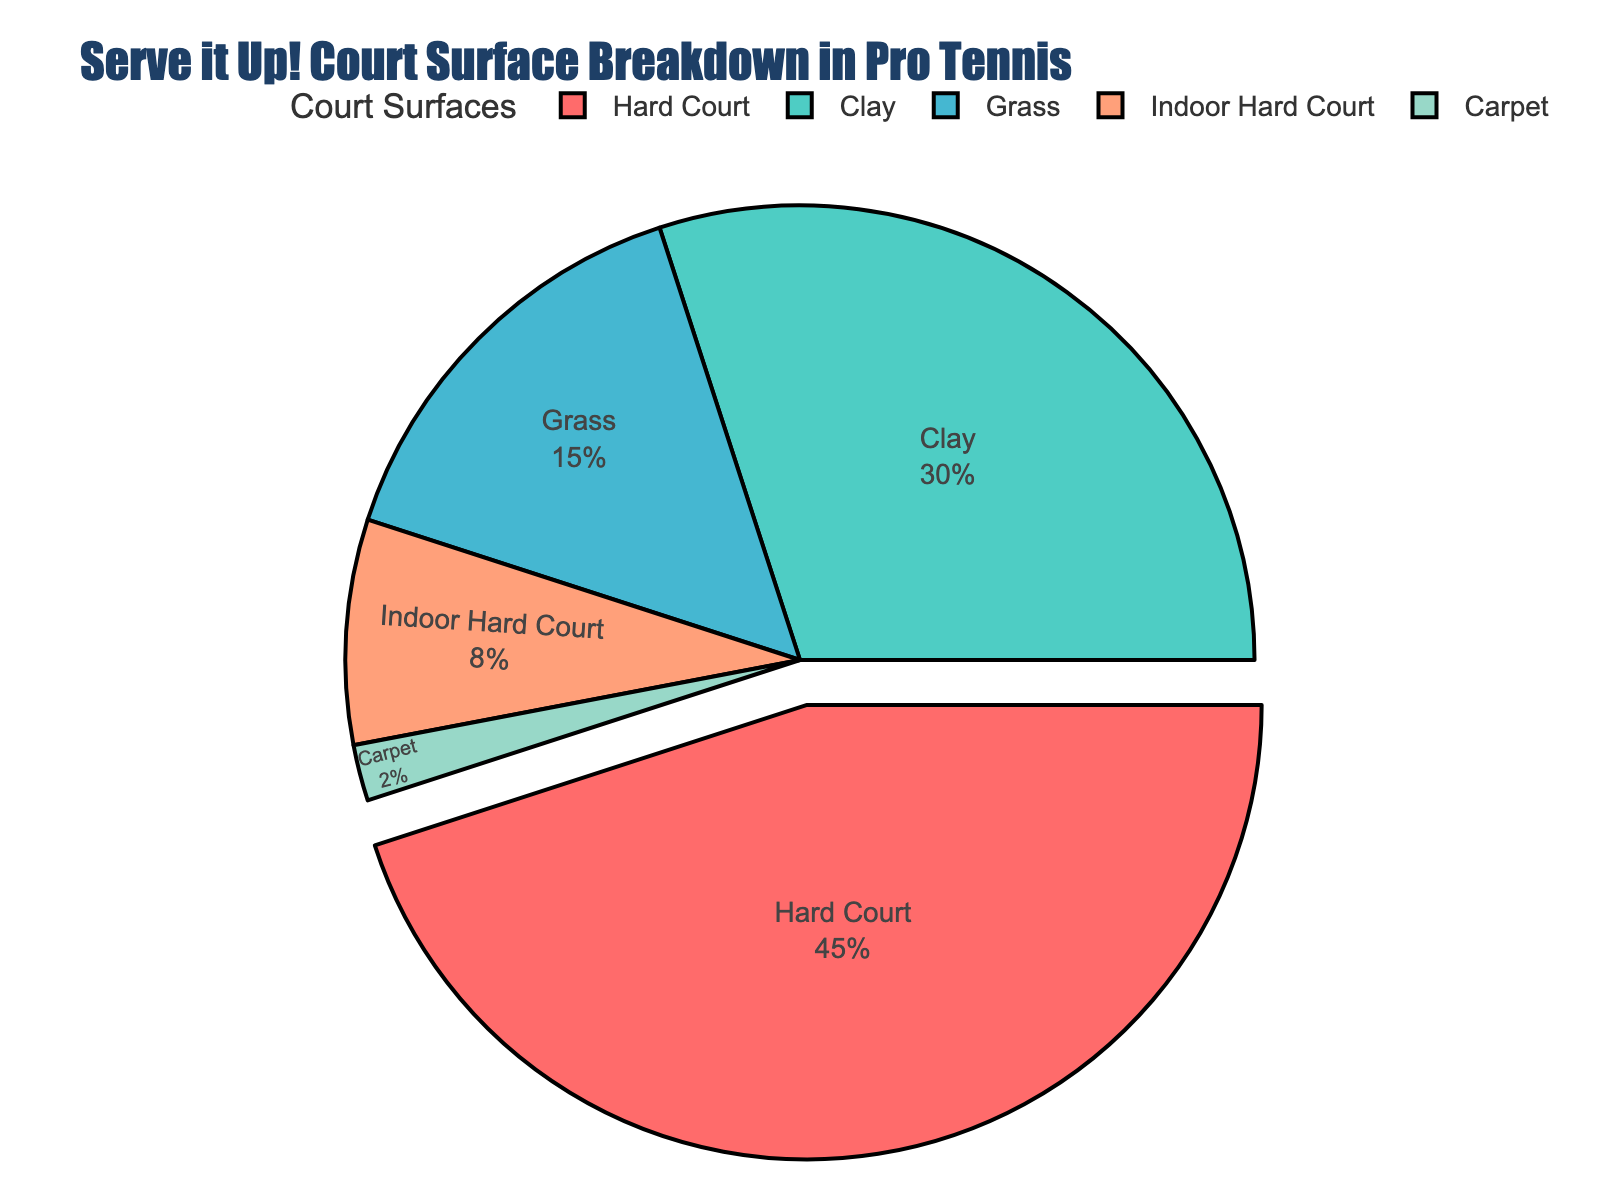What percentage of professional tennis matches are played on hard courts? The pie chart clearly shows the percentage breakdown. The slice representing hard courts is labeled with its percentage.
Answer: 45% What is the combined percentage for clay and grass courts? The percentage for clay courts is 30%, and for grass courts, it is 15%. Adding these two values gives the combined percentage. Therefore, 30% + 15% = 45%.
Answer: 45% Which court surface has the smallest percentage usage in professional tennis tournaments? The pie chart shows various slices with their respective percentages. The smallest slice, associated with 2%, is labeled as Carpet.
Answer: Carpet What is the percentage difference between hard courts and indoor hard courts? From the pie chart, hard courts are 45%, and indoor hard courts are 8%. Subtract the percentage for indoor hard courts from that of hard courts: 45% - 8% = 37%.
Answer: 37% Do clay courts have more utilization than grass and indoor hard courts combined? The percentage for clay courts is 30%. Combining grass (15%) and indoor hard courts (8%) gives 15% + 8% = 23%. Since 30% > 23%, clay courts do have more utilization.
Answer: Yes What color is used to represent clay courts in the pie chart? Observing the pie chart, each slice has a different color. The slice labeled 'Clay' is colored in a distinctive color, which is greenish.
Answer: Greenish Which two court surfaces together make up just over half of the pie chart? Hard court is 45%, and combining it with clay courts (30%) gives 45% + 30% = 75%. This combination exceeds half the chart. Combining hard courts and grass courts is 45% + 15% = 60%, also over half. Hence, both combinations are valid, but the smallest exceeding half is 60%.
Answer: Hard court and Grass By how much does the percentage of hard courts exceed the combined percentage of indoor hard courts and carpet courts? Hard courts are 45%, whereas indoor hard and carpet courts are 8% and 2%, respectively. Combined, they make 8% + 2% = 10%. The difference: 45% - 10% = 35%.
Answer: 35% What visual feature highlights the most commonly used court surface in the pie chart? The pie chart has a segment pulled out slightly from the circle for emphasis. This feature corresponds to the hard court, indicating it as the most commonly used surface.
Answer: Pulled-out segment 